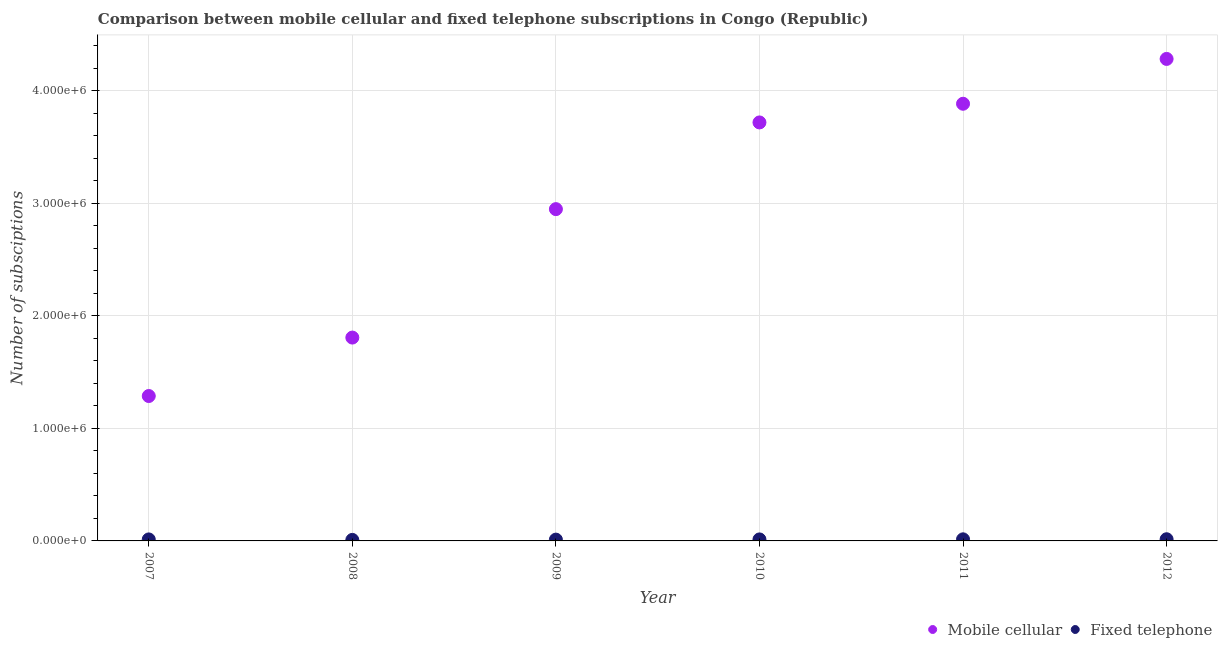How many different coloured dotlines are there?
Ensure brevity in your answer.  2. What is the number of fixed telephone subscriptions in 2010?
Your response must be concise. 1.34e+04. Across all years, what is the maximum number of mobile cellular subscriptions?
Give a very brief answer. 4.28e+06. Across all years, what is the minimum number of fixed telephone subscriptions?
Your answer should be very brief. 9050. In which year was the number of fixed telephone subscriptions maximum?
Keep it short and to the point. 2012. What is the total number of fixed telephone subscriptions in the graph?
Make the answer very short. 7.66e+04. What is the difference between the number of mobile cellular subscriptions in 2009 and that in 2012?
Ensure brevity in your answer.  -1.33e+06. What is the difference between the number of mobile cellular subscriptions in 2012 and the number of fixed telephone subscriptions in 2009?
Keep it short and to the point. 4.27e+06. What is the average number of fixed telephone subscriptions per year?
Provide a short and direct response. 1.28e+04. In the year 2010, what is the difference between the number of fixed telephone subscriptions and number of mobile cellular subscriptions?
Offer a very short reply. -3.71e+06. What is the ratio of the number of mobile cellular subscriptions in 2011 to that in 2012?
Your response must be concise. 0.91. Is the number of mobile cellular subscriptions in 2007 less than that in 2008?
Give a very brief answer. Yes. What is the difference between the highest and the second highest number of fixed telephone subscriptions?
Provide a short and direct response. 732. What is the difference between the highest and the lowest number of fixed telephone subscriptions?
Provide a succinct answer. 5882. Is the number of fixed telephone subscriptions strictly greater than the number of mobile cellular subscriptions over the years?
Offer a terse response. No. Is the number of mobile cellular subscriptions strictly less than the number of fixed telephone subscriptions over the years?
Keep it short and to the point. No. How many dotlines are there?
Your answer should be compact. 2. How many years are there in the graph?
Give a very brief answer. 6. What is the difference between two consecutive major ticks on the Y-axis?
Your answer should be very brief. 1.00e+06. Does the graph contain any zero values?
Your response must be concise. No. Where does the legend appear in the graph?
Offer a very short reply. Bottom right. How many legend labels are there?
Your response must be concise. 2. How are the legend labels stacked?
Offer a very short reply. Horizontal. What is the title of the graph?
Provide a short and direct response. Comparison between mobile cellular and fixed telephone subscriptions in Congo (Republic). Does "Taxes on exports" appear as one of the legend labels in the graph?
Make the answer very short. No. What is the label or title of the X-axis?
Offer a very short reply. Year. What is the label or title of the Y-axis?
Make the answer very short. Number of subsciptions. What is the Number of subsciptions of Mobile cellular in 2007?
Make the answer very short. 1.29e+06. What is the Number of subsciptions in Fixed telephone in 2007?
Give a very brief answer. 1.34e+04. What is the Number of subsciptions of Mobile cellular in 2008?
Offer a terse response. 1.81e+06. What is the Number of subsciptions of Fixed telephone in 2008?
Provide a short and direct response. 9050. What is the Number of subsciptions of Mobile cellular in 2009?
Provide a succinct answer. 2.95e+06. What is the Number of subsciptions in Fixed telephone in 2009?
Offer a terse response. 1.16e+04. What is the Number of subsciptions of Mobile cellular in 2010?
Offer a very short reply. 3.72e+06. What is the Number of subsciptions in Fixed telephone in 2010?
Your answer should be compact. 1.34e+04. What is the Number of subsciptions in Mobile cellular in 2011?
Ensure brevity in your answer.  3.88e+06. What is the Number of subsciptions of Fixed telephone in 2011?
Your answer should be very brief. 1.42e+04. What is the Number of subsciptions in Mobile cellular in 2012?
Ensure brevity in your answer.  4.28e+06. What is the Number of subsciptions of Fixed telephone in 2012?
Offer a very short reply. 1.49e+04. Across all years, what is the maximum Number of subsciptions of Mobile cellular?
Your answer should be compact. 4.28e+06. Across all years, what is the maximum Number of subsciptions in Fixed telephone?
Ensure brevity in your answer.  1.49e+04. Across all years, what is the minimum Number of subsciptions of Mobile cellular?
Give a very brief answer. 1.29e+06. Across all years, what is the minimum Number of subsciptions in Fixed telephone?
Offer a very short reply. 9050. What is the total Number of subsciptions in Mobile cellular in the graph?
Make the answer very short. 1.79e+07. What is the total Number of subsciptions of Fixed telephone in the graph?
Provide a succinct answer. 7.66e+04. What is the difference between the Number of subsciptions of Mobile cellular in 2007 and that in 2008?
Provide a short and direct response. -5.19e+05. What is the difference between the Number of subsciptions of Fixed telephone in 2007 and that in 2008?
Offer a very short reply. 4354. What is the difference between the Number of subsciptions in Mobile cellular in 2007 and that in 2009?
Your response must be concise. -1.66e+06. What is the difference between the Number of subsciptions in Fixed telephone in 2007 and that in 2009?
Give a very brief answer. 1804. What is the difference between the Number of subsciptions of Mobile cellular in 2007 and that in 2010?
Your answer should be very brief. -2.43e+06. What is the difference between the Number of subsciptions in Fixed telephone in 2007 and that in 2010?
Offer a terse response. 4. What is the difference between the Number of subsciptions in Mobile cellular in 2007 and that in 2011?
Your response must be concise. -2.60e+06. What is the difference between the Number of subsciptions of Fixed telephone in 2007 and that in 2011?
Give a very brief answer. -796. What is the difference between the Number of subsciptions of Mobile cellular in 2007 and that in 2012?
Give a very brief answer. -3.00e+06. What is the difference between the Number of subsciptions of Fixed telephone in 2007 and that in 2012?
Give a very brief answer. -1528. What is the difference between the Number of subsciptions of Mobile cellular in 2008 and that in 2009?
Offer a very short reply. -1.14e+06. What is the difference between the Number of subsciptions in Fixed telephone in 2008 and that in 2009?
Keep it short and to the point. -2550. What is the difference between the Number of subsciptions of Mobile cellular in 2008 and that in 2010?
Make the answer very short. -1.91e+06. What is the difference between the Number of subsciptions in Fixed telephone in 2008 and that in 2010?
Your response must be concise. -4350. What is the difference between the Number of subsciptions of Mobile cellular in 2008 and that in 2011?
Make the answer very short. -2.08e+06. What is the difference between the Number of subsciptions in Fixed telephone in 2008 and that in 2011?
Offer a terse response. -5150. What is the difference between the Number of subsciptions in Mobile cellular in 2008 and that in 2012?
Your answer should be compact. -2.48e+06. What is the difference between the Number of subsciptions in Fixed telephone in 2008 and that in 2012?
Your response must be concise. -5882. What is the difference between the Number of subsciptions of Mobile cellular in 2009 and that in 2010?
Keep it short and to the point. -7.70e+05. What is the difference between the Number of subsciptions in Fixed telephone in 2009 and that in 2010?
Make the answer very short. -1800. What is the difference between the Number of subsciptions in Mobile cellular in 2009 and that in 2011?
Ensure brevity in your answer.  -9.36e+05. What is the difference between the Number of subsciptions in Fixed telephone in 2009 and that in 2011?
Your answer should be compact. -2600. What is the difference between the Number of subsciptions of Mobile cellular in 2009 and that in 2012?
Keep it short and to the point. -1.33e+06. What is the difference between the Number of subsciptions of Fixed telephone in 2009 and that in 2012?
Your response must be concise. -3332. What is the difference between the Number of subsciptions of Mobile cellular in 2010 and that in 2011?
Ensure brevity in your answer.  -1.66e+05. What is the difference between the Number of subsciptions of Fixed telephone in 2010 and that in 2011?
Give a very brief answer. -800. What is the difference between the Number of subsciptions of Mobile cellular in 2010 and that in 2012?
Provide a short and direct response. -5.64e+05. What is the difference between the Number of subsciptions in Fixed telephone in 2010 and that in 2012?
Give a very brief answer. -1532. What is the difference between the Number of subsciptions of Mobile cellular in 2011 and that in 2012?
Offer a terse response. -3.98e+05. What is the difference between the Number of subsciptions of Fixed telephone in 2011 and that in 2012?
Ensure brevity in your answer.  -732. What is the difference between the Number of subsciptions of Mobile cellular in 2007 and the Number of subsciptions of Fixed telephone in 2008?
Your answer should be compact. 1.28e+06. What is the difference between the Number of subsciptions of Mobile cellular in 2007 and the Number of subsciptions of Fixed telephone in 2009?
Make the answer very short. 1.28e+06. What is the difference between the Number of subsciptions of Mobile cellular in 2007 and the Number of subsciptions of Fixed telephone in 2010?
Give a very brief answer. 1.27e+06. What is the difference between the Number of subsciptions of Mobile cellular in 2007 and the Number of subsciptions of Fixed telephone in 2011?
Offer a terse response. 1.27e+06. What is the difference between the Number of subsciptions in Mobile cellular in 2007 and the Number of subsciptions in Fixed telephone in 2012?
Make the answer very short. 1.27e+06. What is the difference between the Number of subsciptions in Mobile cellular in 2008 and the Number of subsciptions in Fixed telephone in 2009?
Provide a succinct answer. 1.80e+06. What is the difference between the Number of subsciptions in Mobile cellular in 2008 and the Number of subsciptions in Fixed telephone in 2010?
Make the answer very short. 1.79e+06. What is the difference between the Number of subsciptions in Mobile cellular in 2008 and the Number of subsciptions in Fixed telephone in 2011?
Provide a succinct answer. 1.79e+06. What is the difference between the Number of subsciptions in Mobile cellular in 2008 and the Number of subsciptions in Fixed telephone in 2012?
Offer a very short reply. 1.79e+06. What is the difference between the Number of subsciptions in Mobile cellular in 2009 and the Number of subsciptions in Fixed telephone in 2010?
Provide a succinct answer. 2.93e+06. What is the difference between the Number of subsciptions in Mobile cellular in 2009 and the Number of subsciptions in Fixed telephone in 2011?
Provide a succinct answer. 2.93e+06. What is the difference between the Number of subsciptions of Mobile cellular in 2009 and the Number of subsciptions of Fixed telephone in 2012?
Ensure brevity in your answer.  2.93e+06. What is the difference between the Number of subsciptions of Mobile cellular in 2010 and the Number of subsciptions of Fixed telephone in 2011?
Offer a terse response. 3.70e+06. What is the difference between the Number of subsciptions in Mobile cellular in 2010 and the Number of subsciptions in Fixed telephone in 2012?
Keep it short and to the point. 3.70e+06. What is the difference between the Number of subsciptions of Mobile cellular in 2011 and the Number of subsciptions of Fixed telephone in 2012?
Keep it short and to the point. 3.87e+06. What is the average Number of subsciptions of Mobile cellular per year?
Your answer should be compact. 2.99e+06. What is the average Number of subsciptions of Fixed telephone per year?
Offer a very short reply. 1.28e+04. In the year 2007, what is the difference between the Number of subsciptions of Mobile cellular and Number of subsciptions of Fixed telephone?
Provide a succinct answer. 1.27e+06. In the year 2008, what is the difference between the Number of subsciptions of Mobile cellular and Number of subsciptions of Fixed telephone?
Ensure brevity in your answer.  1.80e+06. In the year 2009, what is the difference between the Number of subsciptions in Mobile cellular and Number of subsciptions in Fixed telephone?
Your answer should be very brief. 2.94e+06. In the year 2010, what is the difference between the Number of subsciptions in Mobile cellular and Number of subsciptions in Fixed telephone?
Ensure brevity in your answer.  3.71e+06. In the year 2011, what is the difference between the Number of subsciptions of Mobile cellular and Number of subsciptions of Fixed telephone?
Your answer should be compact. 3.87e+06. In the year 2012, what is the difference between the Number of subsciptions in Mobile cellular and Number of subsciptions in Fixed telephone?
Keep it short and to the point. 4.27e+06. What is the ratio of the Number of subsciptions in Mobile cellular in 2007 to that in 2008?
Keep it short and to the point. 0.71. What is the ratio of the Number of subsciptions of Fixed telephone in 2007 to that in 2008?
Keep it short and to the point. 1.48. What is the ratio of the Number of subsciptions in Mobile cellular in 2007 to that in 2009?
Ensure brevity in your answer.  0.44. What is the ratio of the Number of subsciptions in Fixed telephone in 2007 to that in 2009?
Your answer should be very brief. 1.16. What is the ratio of the Number of subsciptions of Mobile cellular in 2007 to that in 2010?
Make the answer very short. 0.35. What is the ratio of the Number of subsciptions of Mobile cellular in 2007 to that in 2011?
Give a very brief answer. 0.33. What is the ratio of the Number of subsciptions of Fixed telephone in 2007 to that in 2011?
Keep it short and to the point. 0.94. What is the ratio of the Number of subsciptions in Mobile cellular in 2007 to that in 2012?
Offer a very short reply. 0.3. What is the ratio of the Number of subsciptions of Fixed telephone in 2007 to that in 2012?
Provide a succinct answer. 0.9. What is the ratio of the Number of subsciptions of Mobile cellular in 2008 to that in 2009?
Offer a terse response. 0.61. What is the ratio of the Number of subsciptions in Fixed telephone in 2008 to that in 2009?
Provide a short and direct response. 0.78. What is the ratio of the Number of subsciptions of Mobile cellular in 2008 to that in 2010?
Ensure brevity in your answer.  0.49. What is the ratio of the Number of subsciptions in Fixed telephone in 2008 to that in 2010?
Your response must be concise. 0.68. What is the ratio of the Number of subsciptions in Mobile cellular in 2008 to that in 2011?
Provide a short and direct response. 0.47. What is the ratio of the Number of subsciptions of Fixed telephone in 2008 to that in 2011?
Offer a terse response. 0.64. What is the ratio of the Number of subsciptions in Mobile cellular in 2008 to that in 2012?
Your answer should be very brief. 0.42. What is the ratio of the Number of subsciptions of Fixed telephone in 2008 to that in 2012?
Your answer should be compact. 0.61. What is the ratio of the Number of subsciptions of Mobile cellular in 2009 to that in 2010?
Provide a succinct answer. 0.79. What is the ratio of the Number of subsciptions of Fixed telephone in 2009 to that in 2010?
Give a very brief answer. 0.87. What is the ratio of the Number of subsciptions in Mobile cellular in 2009 to that in 2011?
Your answer should be very brief. 0.76. What is the ratio of the Number of subsciptions in Fixed telephone in 2009 to that in 2011?
Give a very brief answer. 0.82. What is the ratio of the Number of subsciptions of Mobile cellular in 2009 to that in 2012?
Give a very brief answer. 0.69. What is the ratio of the Number of subsciptions of Fixed telephone in 2009 to that in 2012?
Ensure brevity in your answer.  0.78. What is the ratio of the Number of subsciptions in Mobile cellular in 2010 to that in 2011?
Your response must be concise. 0.96. What is the ratio of the Number of subsciptions in Fixed telephone in 2010 to that in 2011?
Your response must be concise. 0.94. What is the ratio of the Number of subsciptions of Mobile cellular in 2010 to that in 2012?
Offer a terse response. 0.87. What is the ratio of the Number of subsciptions in Fixed telephone in 2010 to that in 2012?
Make the answer very short. 0.9. What is the ratio of the Number of subsciptions of Mobile cellular in 2011 to that in 2012?
Ensure brevity in your answer.  0.91. What is the ratio of the Number of subsciptions of Fixed telephone in 2011 to that in 2012?
Your response must be concise. 0.95. What is the difference between the highest and the second highest Number of subsciptions in Mobile cellular?
Your answer should be very brief. 3.98e+05. What is the difference between the highest and the second highest Number of subsciptions in Fixed telephone?
Make the answer very short. 732. What is the difference between the highest and the lowest Number of subsciptions of Mobile cellular?
Your answer should be compact. 3.00e+06. What is the difference between the highest and the lowest Number of subsciptions in Fixed telephone?
Offer a very short reply. 5882. 